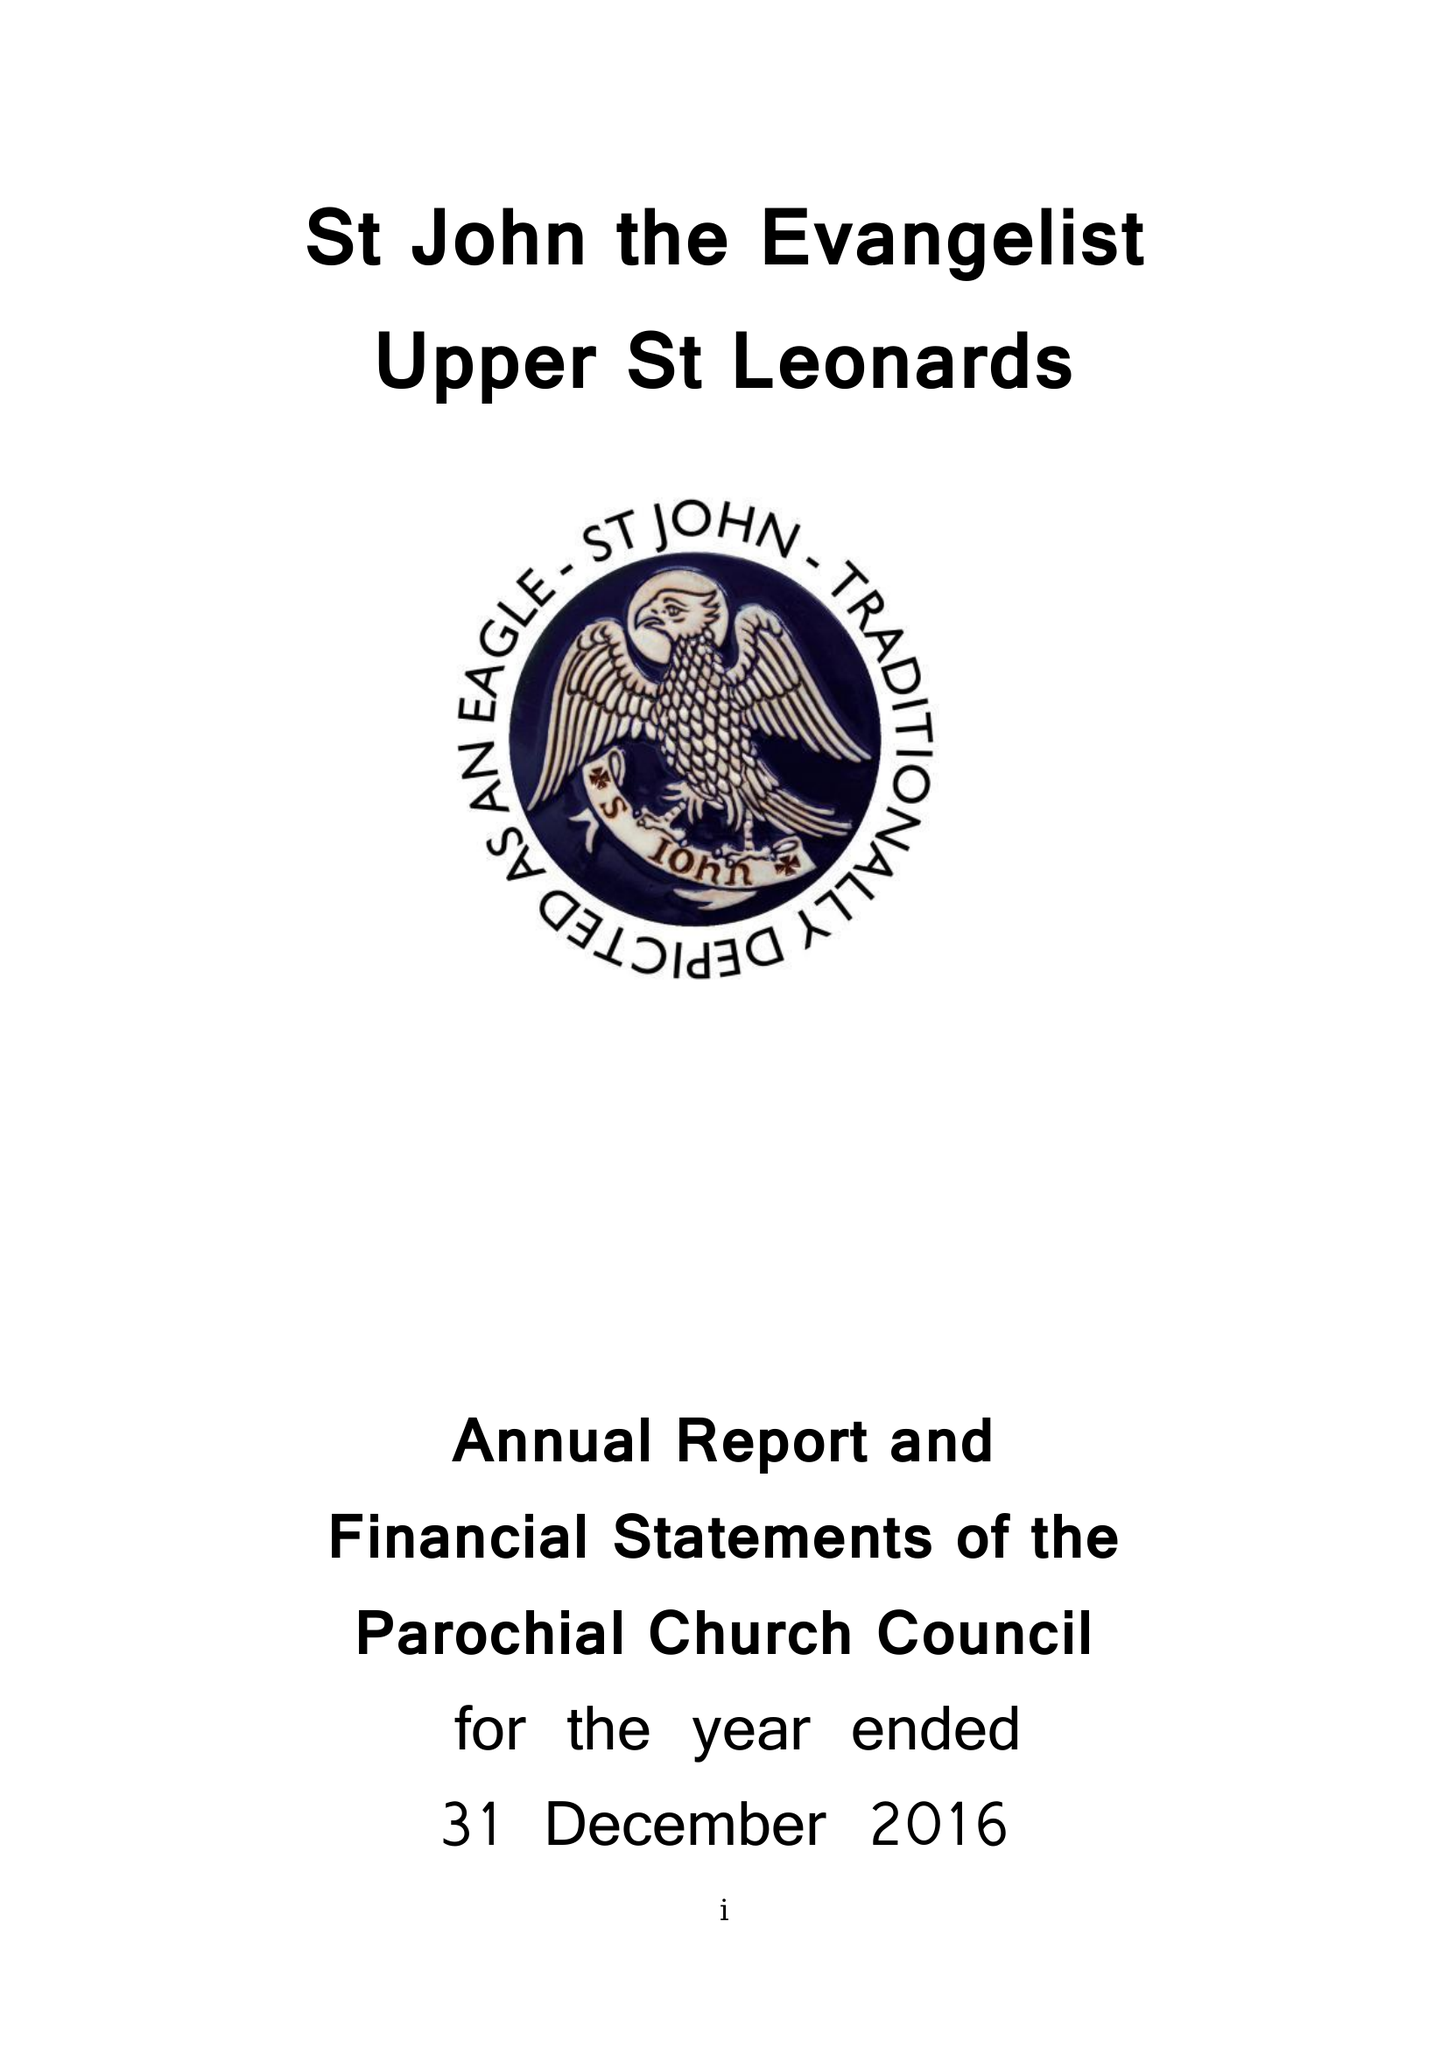What is the value for the address__street_line?
Answer the question using a single word or phrase. PEVENSEY ROAD 